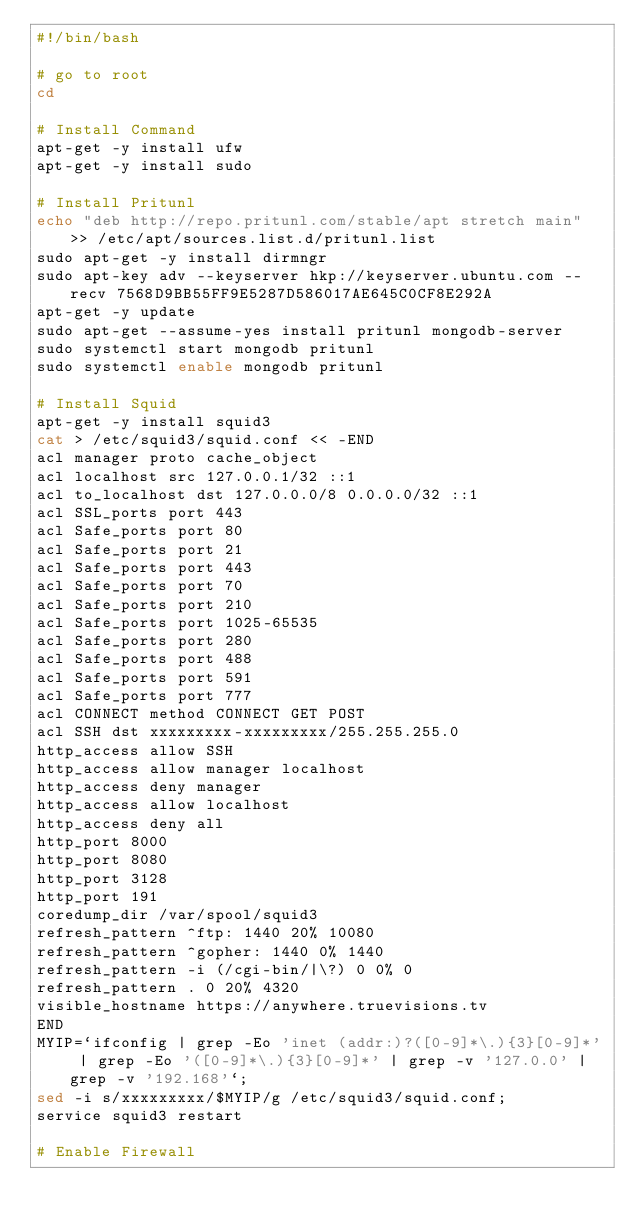<code> <loc_0><loc_0><loc_500><loc_500><_Bash_>#!/bin/bash

# go to root
cd

# Install Command
apt-get -y install ufw
apt-get -y install sudo

# Install Pritunl
echo "deb http://repo.pritunl.com/stable/apt stretch main" >> /etc/apt/sources.list.d/pritunl.list
sudo apt-get -y install dirmngr
sudo apt-key adv --keyserver hkp://keyserver.ubuntu.com --recv 7568D9BB55FF9E5287D586017AE645C0CF8E292A
apt-get -y update
sudo apt-get --assume-yes install pritunl mongodb-server
sudo systemctl start mongodb pritunl
sudo systemctl enable mongodb pritunl

# Install Squid
apt-get -y install squid3
cat > /etc/squid3/squid.conf << -END
acl manager proto cache_object
acl localhost src 127.0.0.1/32 ::1
acl to_localhost dst 127.0.0.0/8 0.0.0.0/32 ::1
acl SSL_ports port 443
acl Safe_ports port 80
acl Safe_ports port 21
acl Safe_ports port 443
acl Safe_ports port 70
acl Safe_ports port 210
acl Safe_ports port 1025-65535
acl Safe_ports port 280
acl Safe_ports port 488
acl Safe_ports port 591
acl Safe_ports port 777
acl CONNECT method CONNECT GET POST
acl SSH dst xxxxxxxxx-xxxxxxxxx/255.255.255.0
http_access allow SSH
http_access allow manager localhost
http_access deny manager
http_access allow localhost
http_access deny all
http_port 8000
http_port 8080
http_port 3128
http_port 191
coredump_dir /var/spool/squid3
refresh_pattern ^ftp: 1440 20% 10080
refresh_pattern ^gopher: 1440 0% 1440
refresh_pattern -i (/cgi-bin/|\?) 0 0% 0
refresh_pattern . 0 20% 4320
visible_hostname https://anywhere.truevisions.tv
END
MYIP=`ifconfig | grep -Eo 'inet (addr:)?([0-9]*\.){3}[0-9]*' | grep -Eo '([0-9]*\.){3}[0-9]*' | grep -v '127.0.0' | grep -v '192.168'`;
sed -i s/xxxxxxxxx/$MYIP/g /etc/squid3/squid.conf;
service squid3 restart

# Enable Firewall</code> 